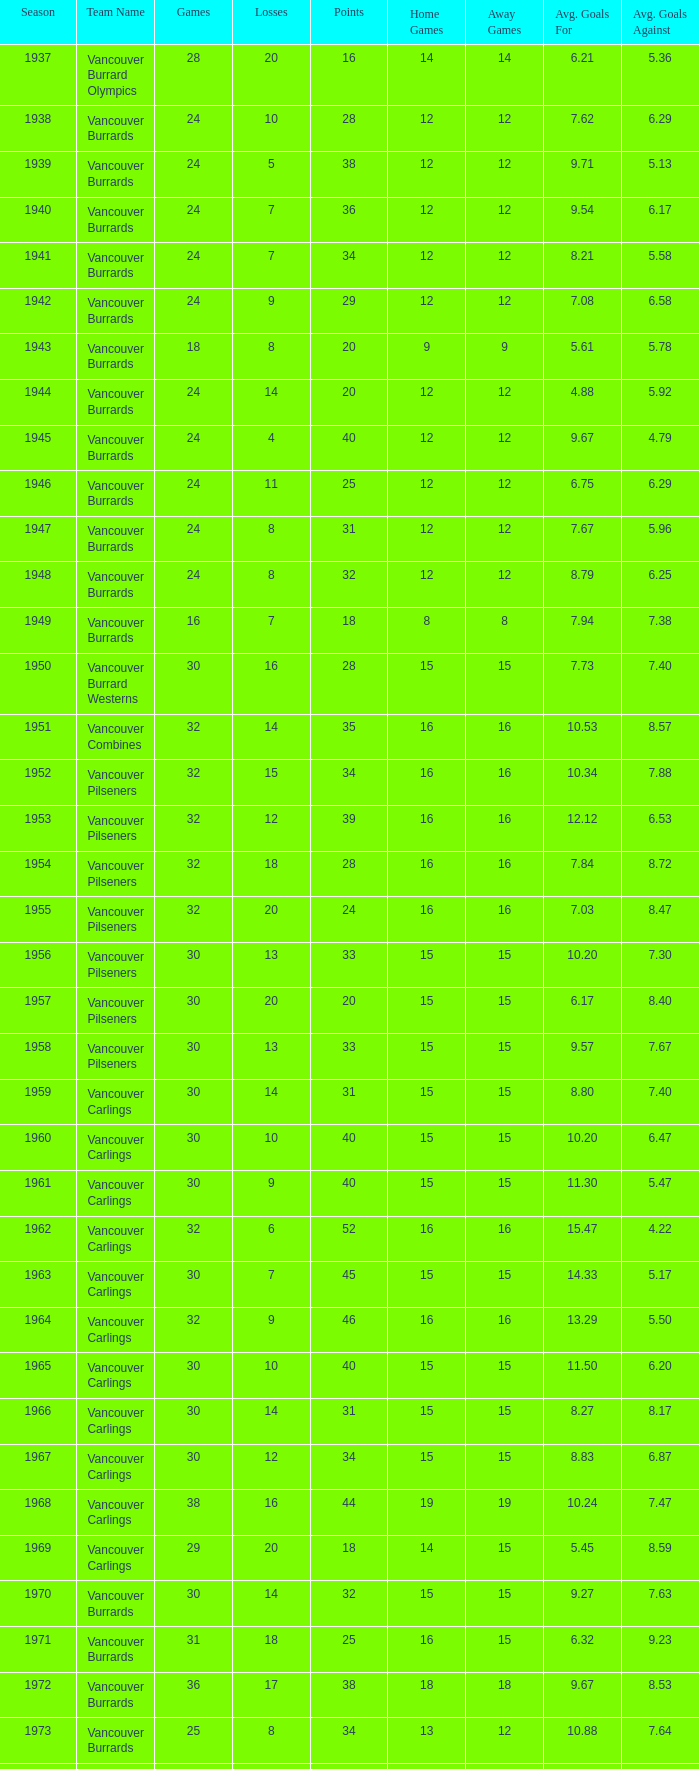What's the lowest number of points with fewer than 8 losses and fewer than 24 games for the vancouver burrards? 18.0. 